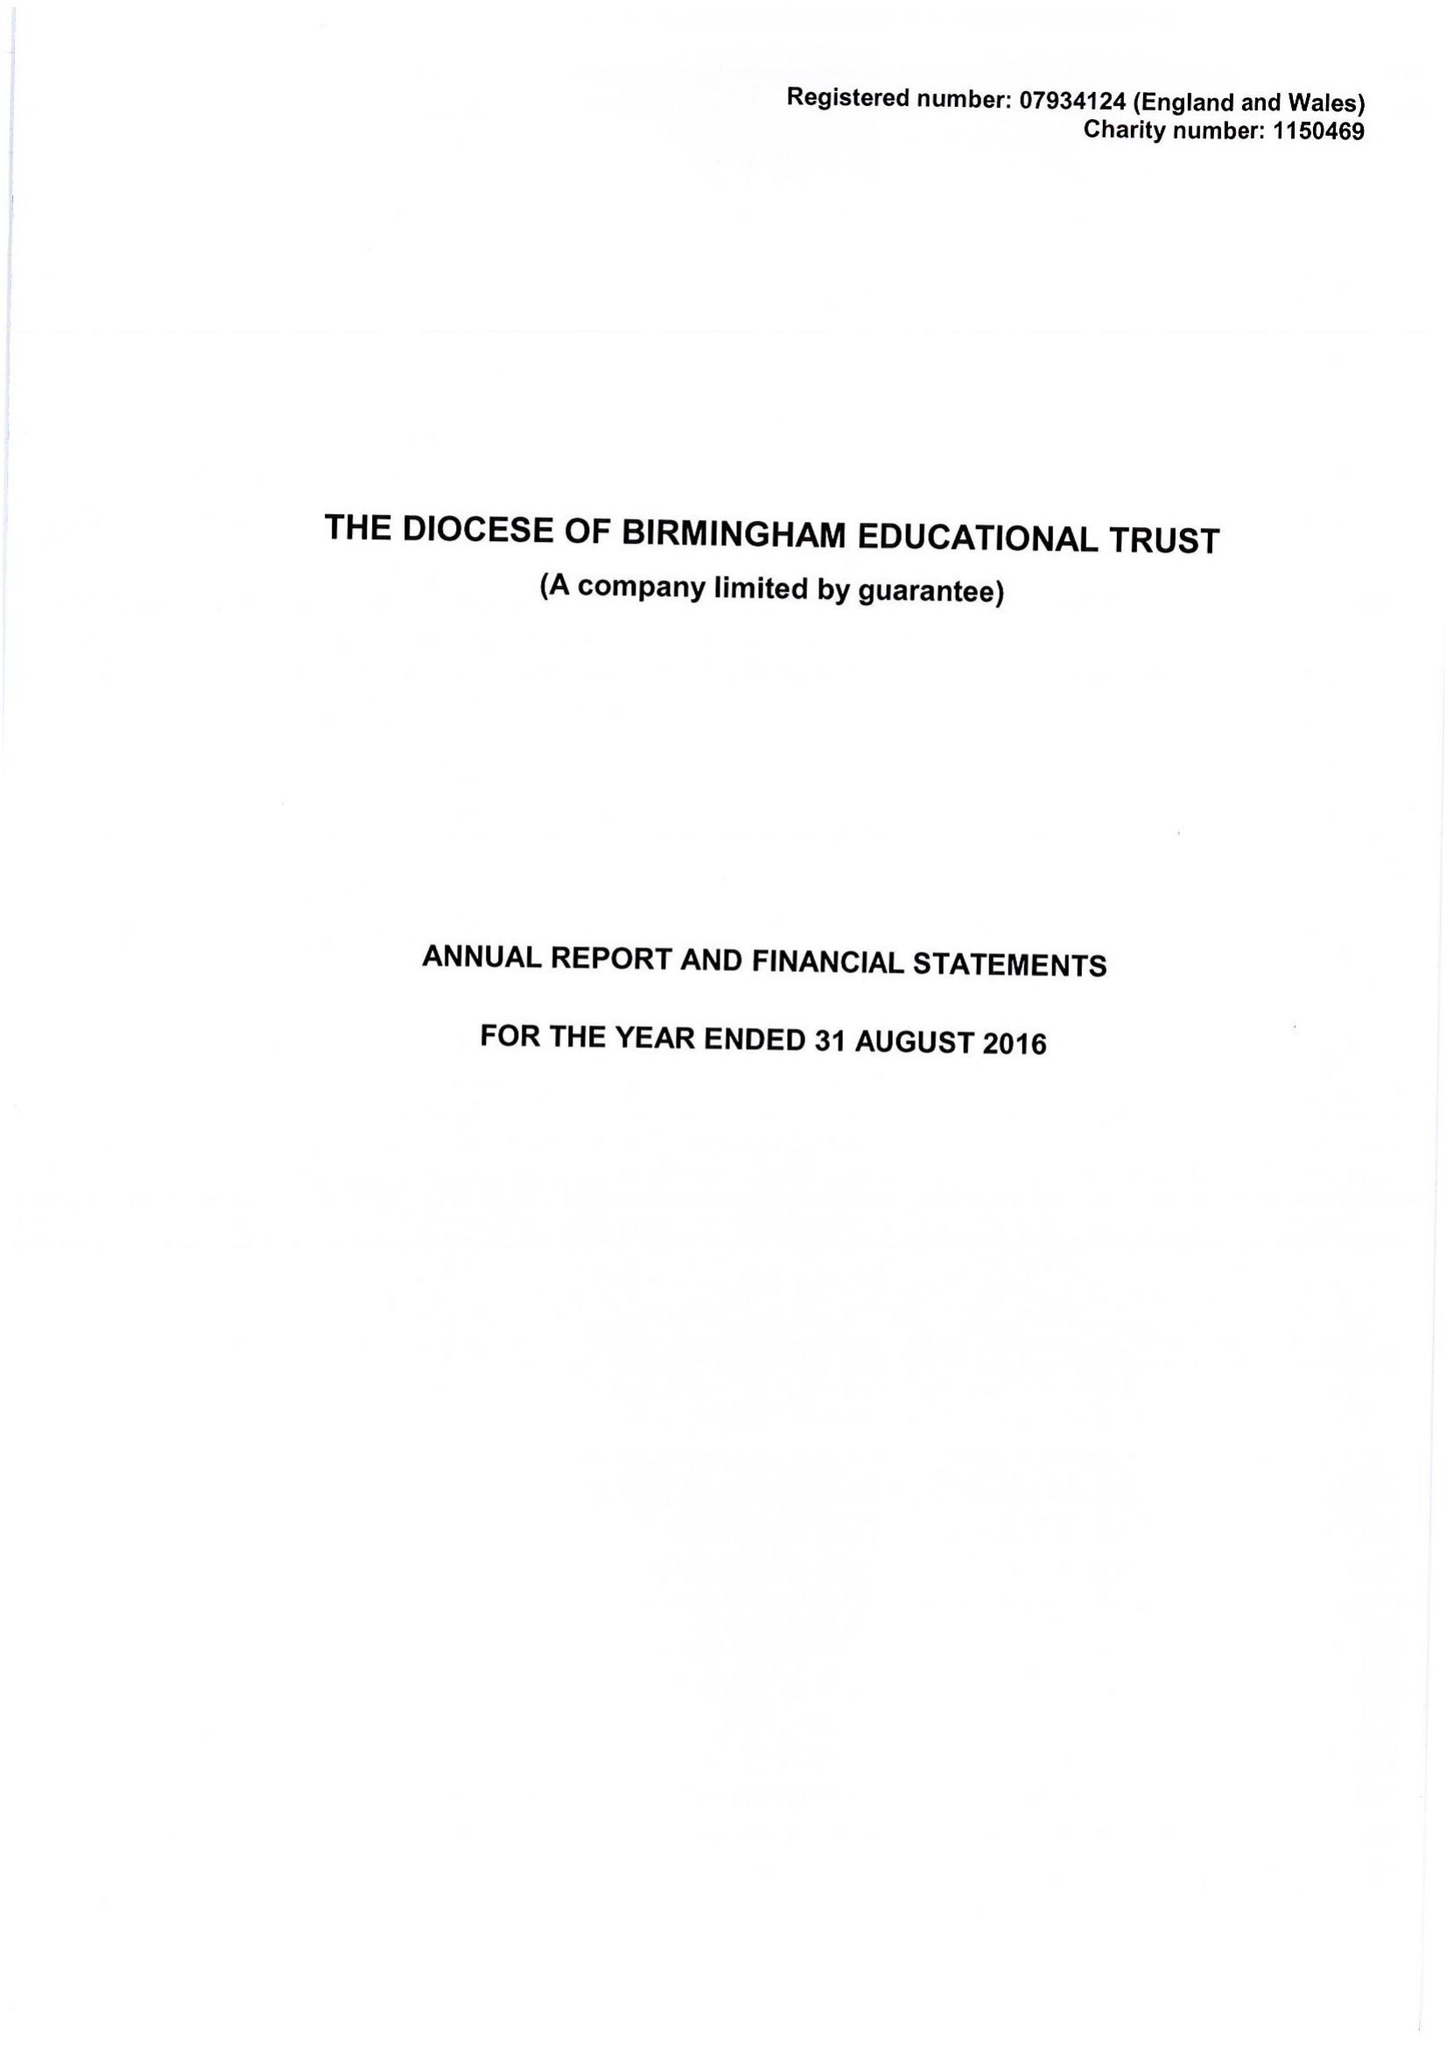What is the value for the report_date?
Answer the question using a single word or phrase. 2016-08-31 